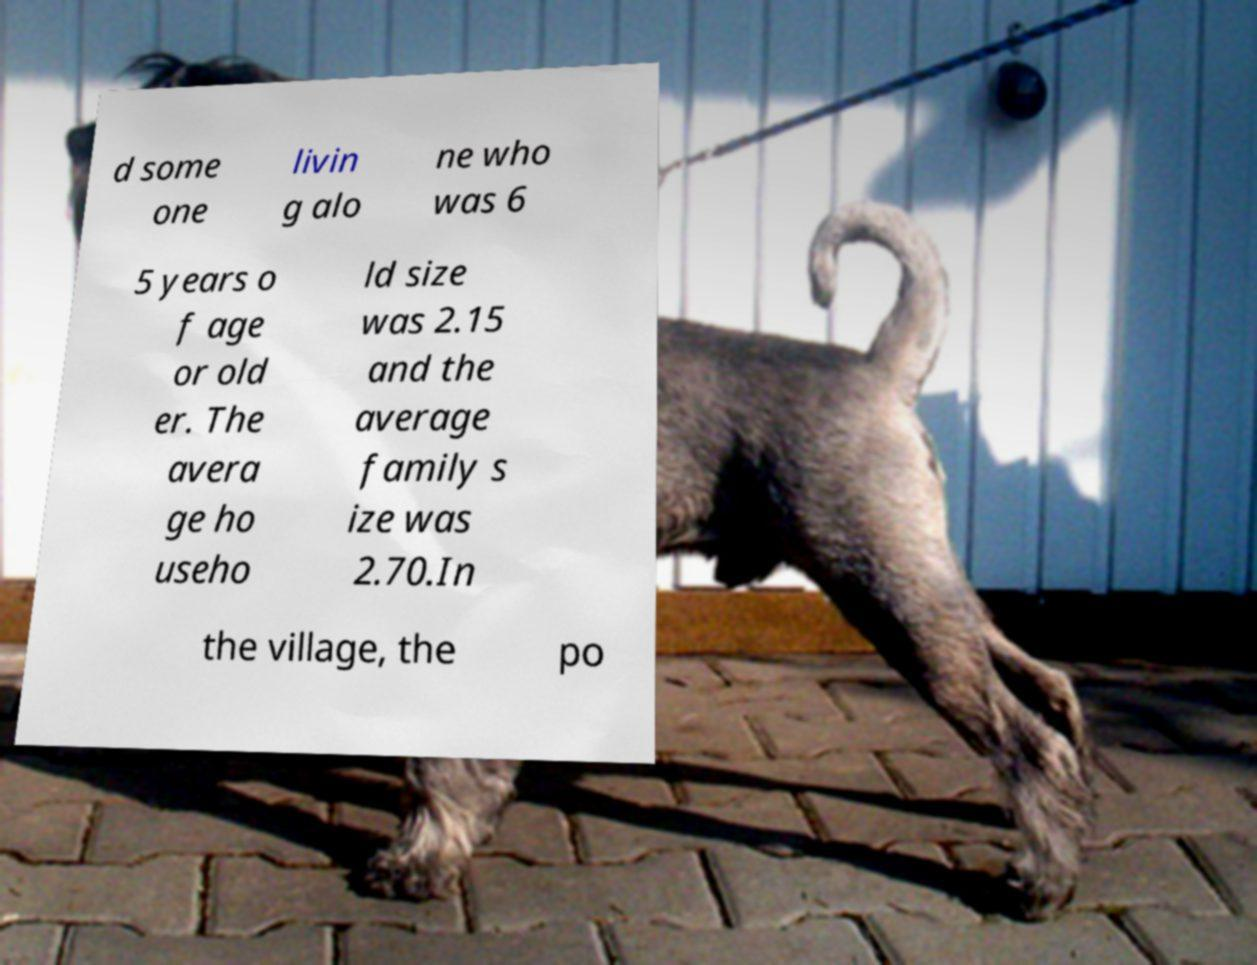Can you accurately transcribe the text from the provided image for me? d some one livin g alo ne who was 6 5 years o f age or old er. The avera ge ho useho ld size was 2.15 and the average family s ize was 2.70.In the village, the po 